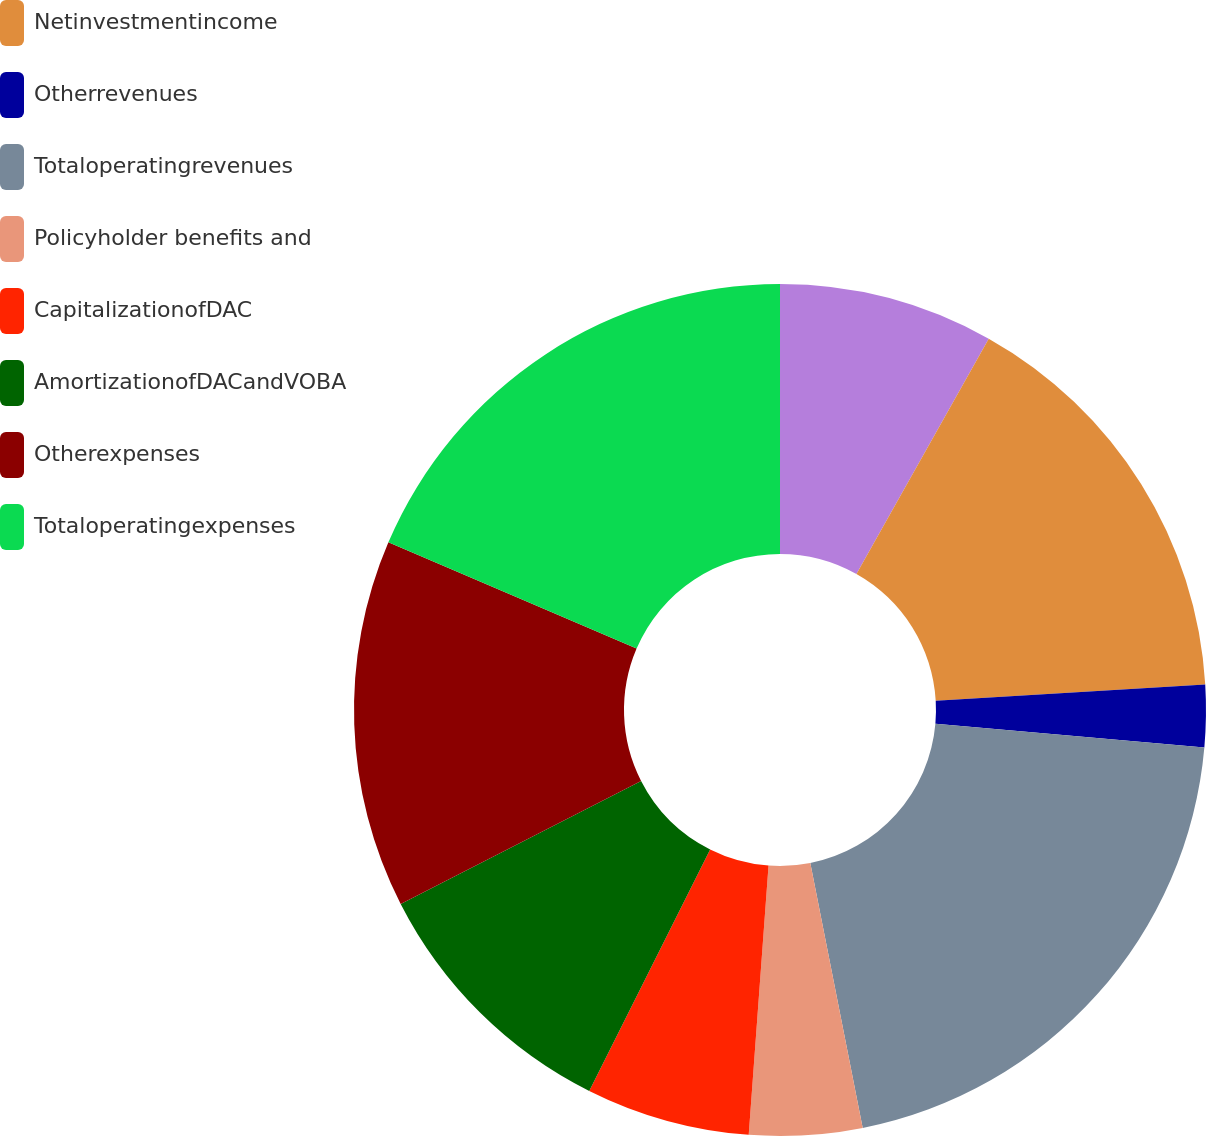Convert chart to OTSL. <chart><loc_0><loc_0><loc_500><loc_500><pie_chart><ecel><fcel>Netinvestmentincome<fcel>Otherrevenues<fcel>Totaloperatingrevenues<fcel>Policyholder benefits and<fcel>CapitalizationofDAC<fcel>AmortizationofDACandVOBA<fcel>Otherexpenses<fcel>Totaloperatingexpenses<nl><fcel>8.15%<fcel>15.9%<fcel>2.35%<fcel>20.49%<fcel>4.28%<fcel>6.22%<fcel>10.09%<fcel>13.96%<fcel>18.56%<nl></chart> 